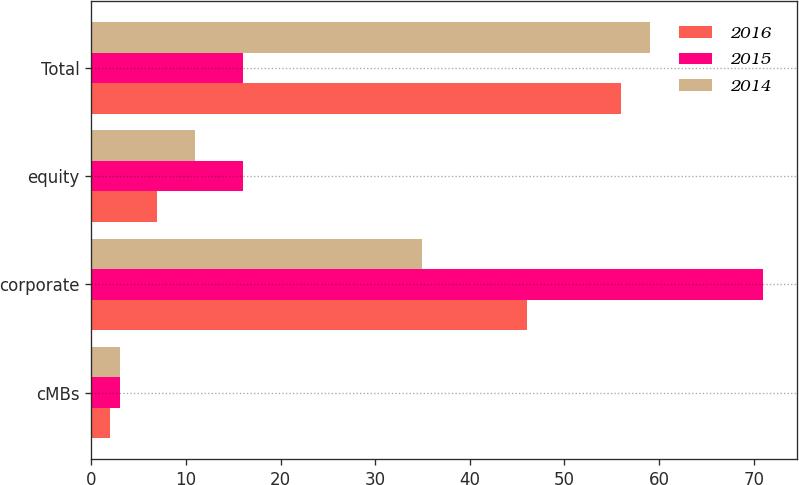Convert chart to OTSL. <chart><loc_0><loc_0><loc_500><loc_500><stacked_bar_chart><ecel><fcel>cMBs<fcel>corporate<fcel>equity<fcel>Total<nl><fcel>2016<fcel>2<fcel>46<fcel>7<fcel>56<nl><fcel>2015<fcel>3<fcel>71<fcel>16<fcel>16<nl><fcel>2014<fcel>3<fcel>35<fcel>11<fcel>59<nl></chart> 